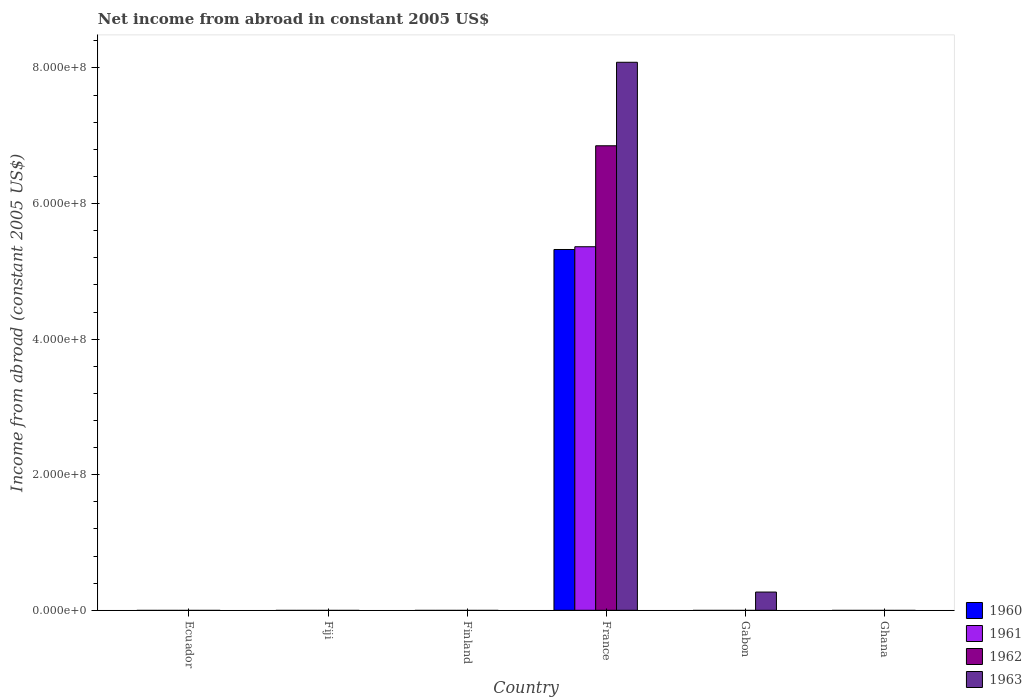How many different coloured bars are there?
Make the answer very short. 4. How many bars are there on the 1st tick from the left?
Provide a succinct answer. 0. How many bars are there on the 2nd tick from the right?
Ensure brevity in your answer.  1. What is the label of the 2nd group of bars from the left?
Your answer should be compact. Fiji. In how many cases, is the number of bars for a given country not equal to the number of legend labels?
Offer a very short reply. 5. What is the net income from abroad in 1962 in Ghana?
Your answer should be very brief. 0. Across all countries, what is the maximum net income from abroad in 1960?
Offer a very short reply. 5.32e+08. What is the total net income from abroad in 1962 in the graph?
Keep it short and to the point. 6.85e+08. What is the average net income from abroad in 1960 per country?
Offer a terse response. 8.87e+07. What is the difference between the net income from abroad of/in 1962 and net income from abroad of/in 1963 in France?
Offer a terse response. -1.23e+08. What is the difference between the highest and the lowest net income from abroad in 1961?
Provide a short and direct response. 5.36e+08. In how many countries, is the net income from abroad in 1963 greater than the average net income from abroad in 1963 taken over all countries?
Give a very brief answer. 1. Is it the case that in every country, the sum of the net income from abroad in 1960 and net income from abroad in 1961 is greater than the sum of net income from abroad in 1962 and net income from abroad in 1963?
Provide a short and direct response. No. Are all the bars in the graph horizontal?
Your answer should be compact. No. What is the difference between two consecutive major ticks on the Y-axis?
Offer a terse response. 2.00e+08. Does the graph contain any zero values?
Keep it short and to the point. Yes. What is the title of the graph?
Your answer should be very brief. Net income from abroad in constant 2005 US$. What is the label or title of the X-axis?
Your answer should be very brief. Country. What is the label or title of the Y-axis?
Offer a terse response. Income from abroad (constant 2005 US$). What is the Income from abroad (constant 2005 US$) in 1960 in Ecuador?
Provide a succinct answer. 0. What is the Income from abroad (constant 2005 US$) of 1962 in Ecuador?
Make the answer very short. 0. What is the Income from abroad (constant 2005 US$) of 1963 in Ecuador?
Provide a succinct answer. 0. What is the Income from abroad (constant 2005 US$) in 1960 in Fiji?
Offer a very short reply. 0. What is the Income from abroad (constant 2005 US$) in 1962 in Fiji?
Make the answer very short. 0. What is the Income from abroad (constant 2005 US$) in 1963 in Fiji?
Make the answer very short. 0. What is the Income from abroad (constant 2005 US$) in 1960 in France?
Give a very brief answer. 5.32e+08. What is the Income from abroad (constant 2005 US$) of 1961 in France?
Offer a very short reply. 5.36e+08. What is the Income from abroad (constant 2005 US$) of 1962 in France?
Your answer should be compact. 6.85e+08. What is the Income from abroad (constant 2005 US$) in 1963 in France?
Offer a very short reply. 8.08e+08. What is the Income from abroad (constant 2005 US$) of 1961 in Gabon?
Your answer should be very brief. 0. What is the Income from abroad (constant 2005 US$) of 1963 in Gabon?
Your response must be concise. 2.69e+07. What is the Income from abroad (constant 2005 US$) in 1960 in Ghana?
Ensure brevity in your answer.  0. What is the Income from abroad (constant 2005 US$) in 1961 in Ghana?
Your answer should be compact. 0. What is the Income from abroad (constant 2005 US$) in 1963 in Ghana?
Make the answer very short. 0. Across all countries, what is the maximum Income from abroad (constant 2005 US$) of 1960?
Provide a succinct answer. 5.32e+08. Across all countries, what is the maximum Income from abroad (constant 2005 US$) of 1961?
Provide a succinct answer. 5.36e+08. Across all countries, what is the maximum Income from abroad (constant 2005 US$) in 1962?
Make the answer very short. 6.85e+08. Across all countries, what is the maximum Income from abroad (constant 2005 US$) in 1963?
Offer a terse response. 8.08e+08. What is the total Income from abroad (constant 2005 US$) in 1960 in the graph?
Make the answer very short. 5.32e+08. What is the total Income from abroad (constant 2005 US$) in 1961 in the graph?
Your answer should be very brief. 5.36e+08. What is the total Income from abroad (constant 2005 US$) of 1962 in the graph?
Your answer should be very brief. 6.85e+08. What is the total Income from abroad (constant 2005 US$) in 1963 in the graph?
Ensure brevity in your answer.  8.35e+08. What is the difference between the Income from abroad (constant 2005 US$) in 1963 in France and that in Gabon?
Ensure brevity in your answer.  7.81e+08. What is the difference between the Income from abroad (constant 2005 US$) of 1960 in France and the Income from abroad (constant 2005 US$) of 1963 in Gabon?
Offer a very short reply. 5.05e+08. What is the difference between the Income from abroad (constant 2005 US$) of 1961 in France and the Income from abroad (constant 2005 US$) of 1963 in Gabon?
Offer a very short reply. 5.09e+08. What is the difference between the Income from abroad (constant 2005 US$) in 1962 in France and the Income from abroad (constant 2005 US$) in 1963 in Gabon?
Ensure brevity in your answer.  6.58e+08. What is the average Income from abroad (constant 2005 US$) in 1960 per country?
Make the answer very short. 8.87e+07. What is the average Income from abroad (constant 2005 US$) of 1961 per country?
Offer a very short reply. 8.94e+07. What is the average Income from abroad (constant 2005 US$) of 1962 per country?
Keep it short and to the point. 1.14e+08. What is the average Income from abroad (constant 2005 US$) in 1963 per country?
Provide a short and direct response. 1.39e+08. What is the difference between the Income from abroad (constant 2005 US$) of 1960 and Income from abroad (constant 2005 US$) of 1961 in France?
Your answer should be compact. -4.05e+06. What is the difference between the Income from abroad (constant 2005 US$) in 1960 and Income from abroad (constant 2005 US$) in 1962 in France?
Ensure brevity in your answer.  -1.53e+08. What is the difference between the Income from abroad (constant 2005 US$) in 1960 and Income from abroad (constant 2005 US$) in 1963 in France?
Offer a terse response. -2.76e+08. What is the difference between the Income from abroad (constant 2005 US$) of 1961 and Income from abroad (constant 2005 US$) of 1962 in France?
Ensure brevity in your answer.  -1.49e+08. What is the difference between the Income from abroad (constant 2005 US$) of 1961 and Income from abroad (constant 2005 US$) of 1963 in France?
Offer a terse response. -2.72e+08. What is the difference between the Income from abroad (constant 2005 US$) in 1962 and Income from abroad (constant 2005 US$) in 1963 in France?
Your answer should be very brief. -1.23e+08. What is the ratio of the Income from abroad (constant 2005 US$) in 1963 in France to that in Gabon?
Your response must be concise. 30.04. What is the difference between the highest and the lowest Income from abroad (constant 2005 US$) of 1960?
Your answer should be compact. 5.32e+08. What is the difference between the highest and the lowest Income from abroad (constant 2005 US$) in 1961?
Provide a succinct answer. 5.36e+08. What is the difference between the highest and the lowest Income from abroad (constant 2005 US$) in 1962?
Your answer should be compact. 6.85e+08. What is the difference between the highest and the lowest Income from abroad (constant 2005 US$) of 1963?
Give a very brief answer. 8.08e+08. 